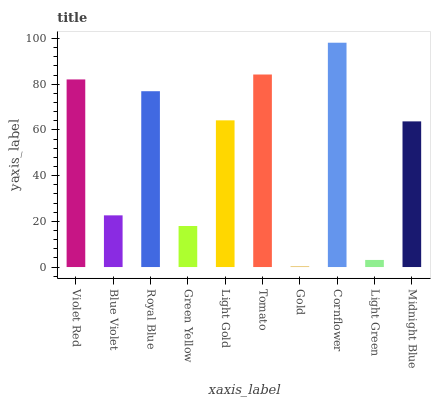Is Blue Violet the minimum?
Answer yes or no. No. Is Blue Violet the maximum?
Answer yes or no. No. Is Violet Red greater than Blue Violet?
Answer yes or no. Yes. Is Blue Violet less than Violet Red?
Answer yes or no. Yes. Is Blue Violet greater than Violet Red?
Answer yes or no. No. Is Violet Red less than Blue Violet?
Answer yes or no. No. Is Light Gold the high median?
Answer yes or no. Yes. Is Midnight Blue the low median?
Answer yes or no. Yes. Is Gold the high median?
Answer yes or no. No. Is Royal Blue the low median?
Answer yes or no. No. 